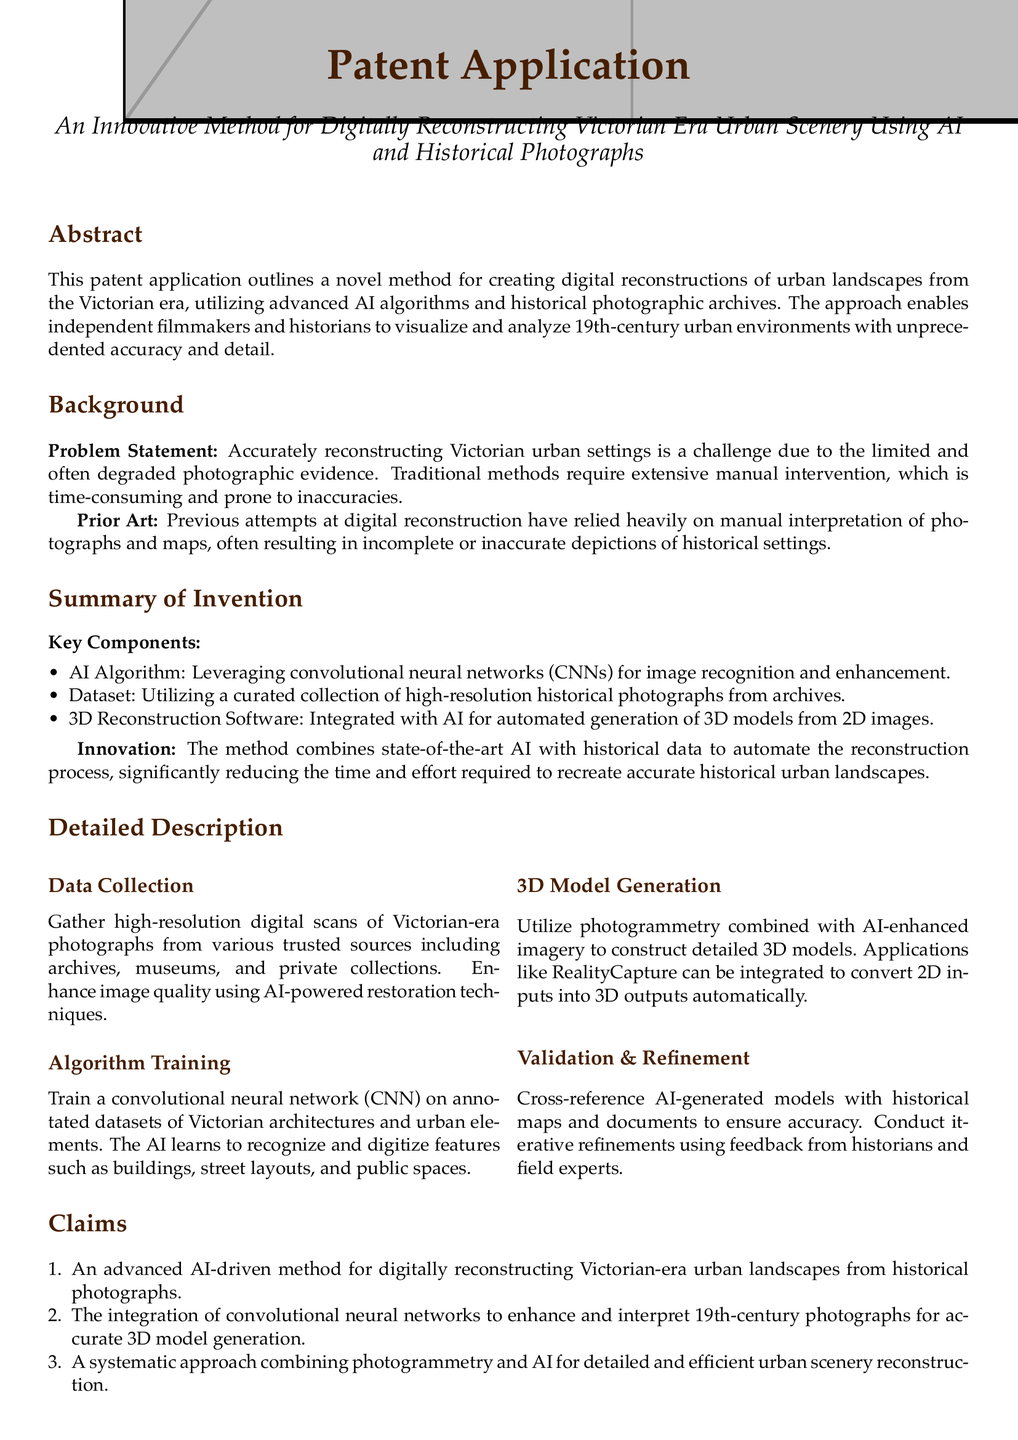What is the title of the patent application? The title is stated in the document header, which indicates the specific focus of the invention.
Answer: An Innovative Method for Digitally Reconstructing Victorian Era Urban Scenery Using AI and Historical Photographs What is the key technology used in the reconstruction method? The key technology mentioned in the document is a specific type of AI algorithm that enhances image recognition.
Answer: Convolutional neural networks (CNNs) How does the method aid filmmakers? The document details how the method provides resources for filmmakers recreating historical settings, highlighting its usefulness in a specific field.
Answer: Creating historically accurate settings What is one of the benefits highlighted in the document? The benefits section outlines several advantages of the invention, emphasizing cultural and educational aspects.
Answer: Cultural Heritage Preservation How does the method ensure accuracy in model generation? The document describes a systematic approach for verification, which involves input from experts to maintain high standards.
Answer: Cross-reference with historical maps and documents What type of datasets does the CNN train on? The document specifies the kind of data that is important for the training of the AI algorithm to perform effectively.
Answer: Annotated datasets of Victorian architectures and urban elements What is the last section of the patent application? This question refers to the organization of the document, specifically focusing on its concluding material.
Answer: Example Use Case How does AI contribute to image quality? The document mentions a specific application of AI that enhances the quality of images sourced from historical records.
Answer: AI-powered restoration techniques 